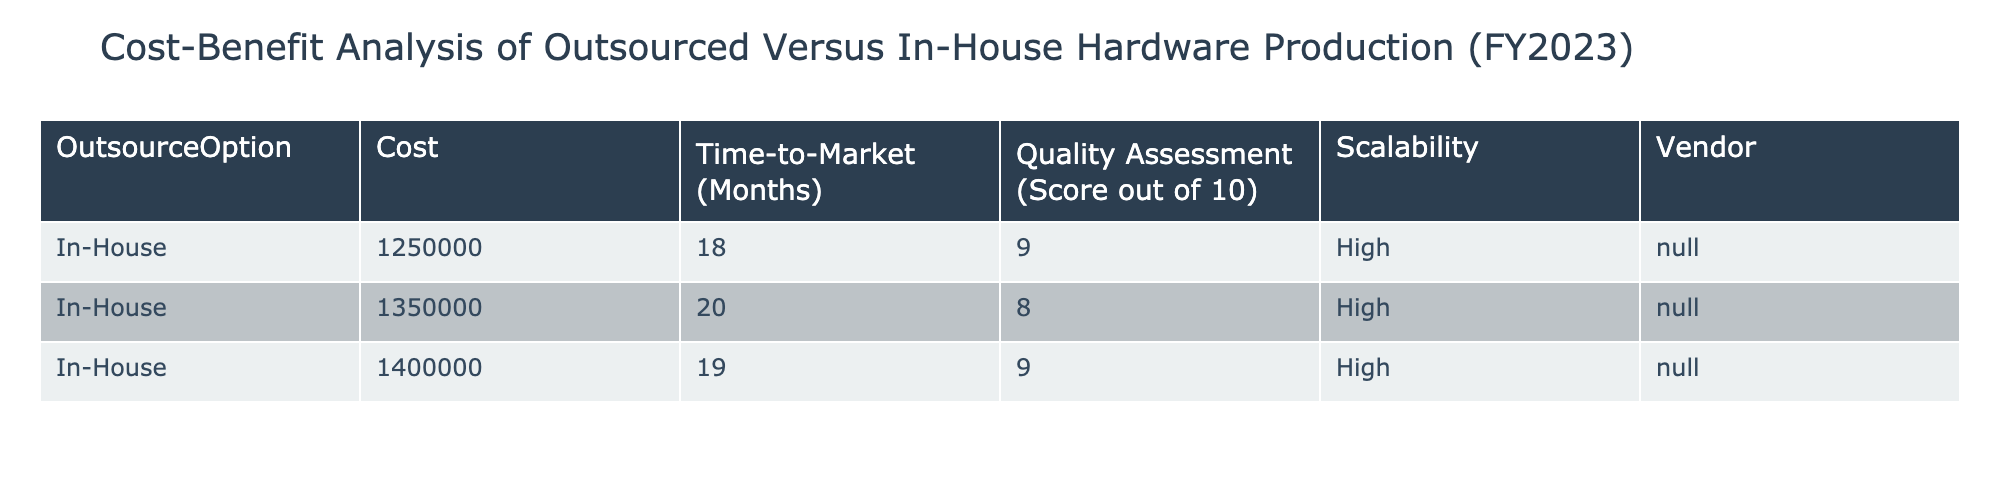What is the cost of the first in-house production option? The table lists three in-house production options with their corresponding costs. The first option has a cost value of 1,250,000.
Answer: 1,250,000 What is the time-to-market for the second in-house production option? Referring to the data in the table, the time-to-market for the second in-house production option is clearly stated as 20 months.
Answer: 20 months What is the average quality assessment score of the in-house production options? To find the average, we add the quality scores of all in-house options: (9 + 8 + 9) = 26. The number of in-house options is 3, so the average score is 26/3 = 8.67.
Answer: 8.67 Is the scalability for in-house production options rated as high? Examining the data, all entries for in-house production show scalability rated as high, so the answer is yes.
Answer: Yes What is the cost difference between the highest and lowest in-house production options? The highest cost for in-house options is 1,400,000, and the lowest is 1,250,000. The difference is calculated as 1,400,000 - 1,250,000 = 150,000.
Answer: 150,000 How many months will it take for the in-house option with the highest quality score to be market-ready? Looking at the quality scores, the highest score of 9 appears in two in-house options, 1,250,000 and 1,400,000. The corresponding time-to-market for the first option is 18 months and for the second, it’s 19 months. Since we only need one, we can take either; thus the answer is 18 or 19 months.
Answer: 18 or 19 months Is there any in-house production option with a cost exceeding 1.3 million? By checking the cost values, only two options exceed this amount: 1,350,000 and 1,400,000, so the answer is yes.
Answer: Yes What is the total cost of all in-house production options combined? We sum the costs: 1,250,000 + 1,350,000 + 1,400,000 = 4,000,000. This total represents the cumulative cost of all in-house options.
Answer: 4,000,000 What is the median quality assessment score for the in-house production options? The quality scores listed are 9, 8, and 9, and when arranged in ascending order, we have 8, 9, 9. The median value is the middle score, which is 9.
Answer: 9 